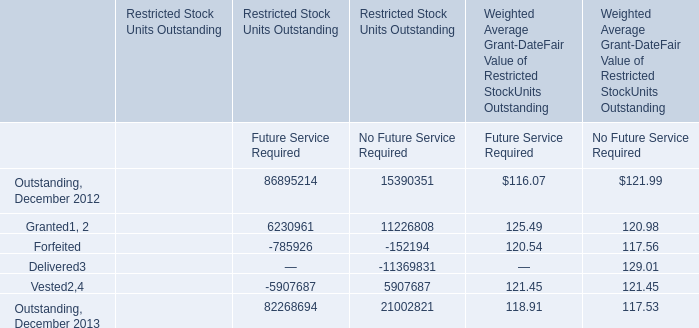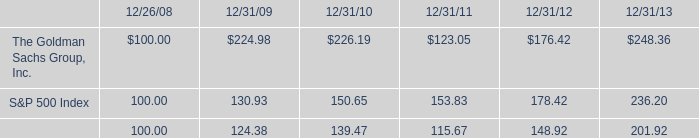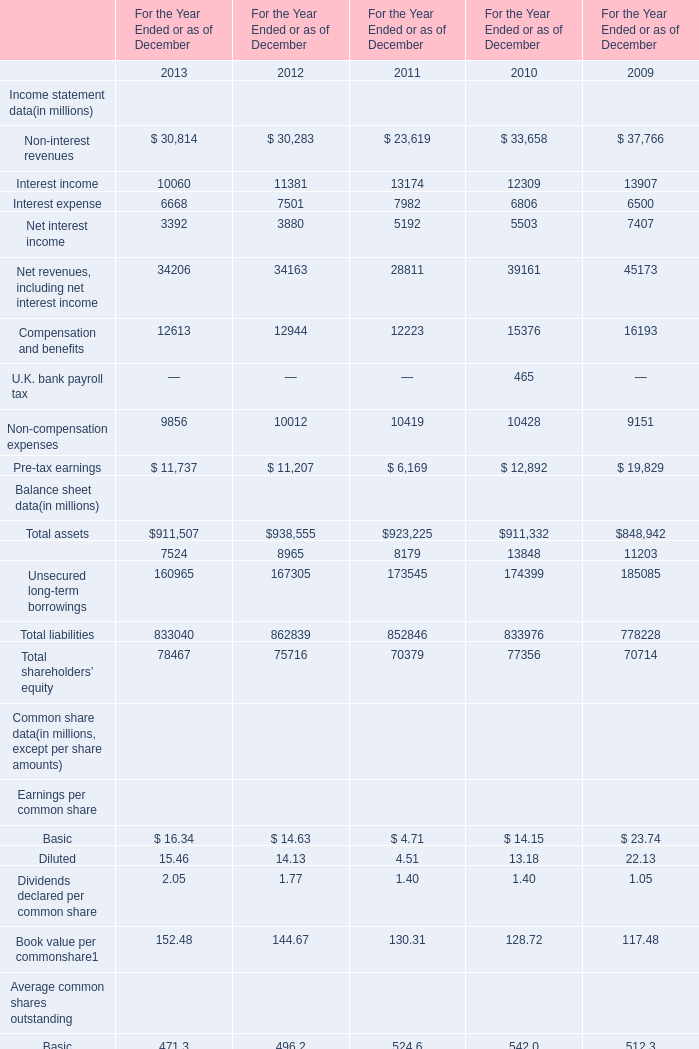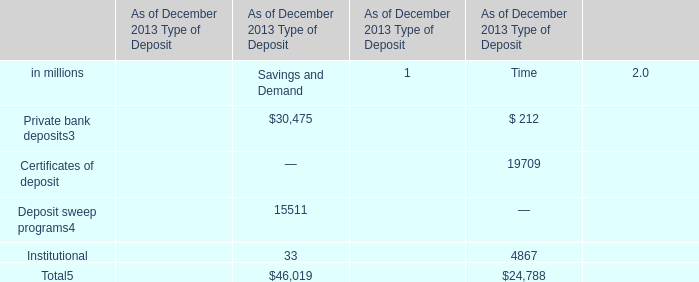What is the average value of Private bank deposits3 for Savings and Demand and Outstanding, for Future Service Required for Weighted Average Grant-DateFair Value of Restricted StockUnits Outstanding in 2013? 
Computations: ((30475 + 118.91) / 2)
Answer: 15296.955. 